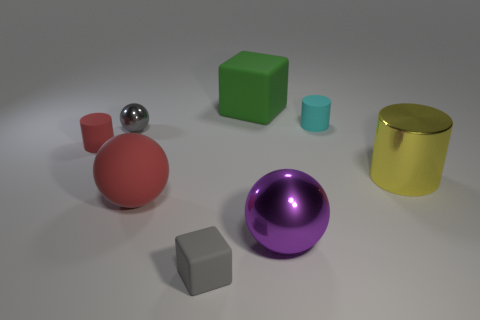What is the largest object in this image? The largest object in the image appears to be the golden cylinder, due to its height and volume compared to the other items. What materials do the objects seem to be made out of? The objects appear to be made from various materials: the spheres seem metallic, the cube and the cylinder look plastic or metallic, and the smaller cube might be stone or ceramic. 